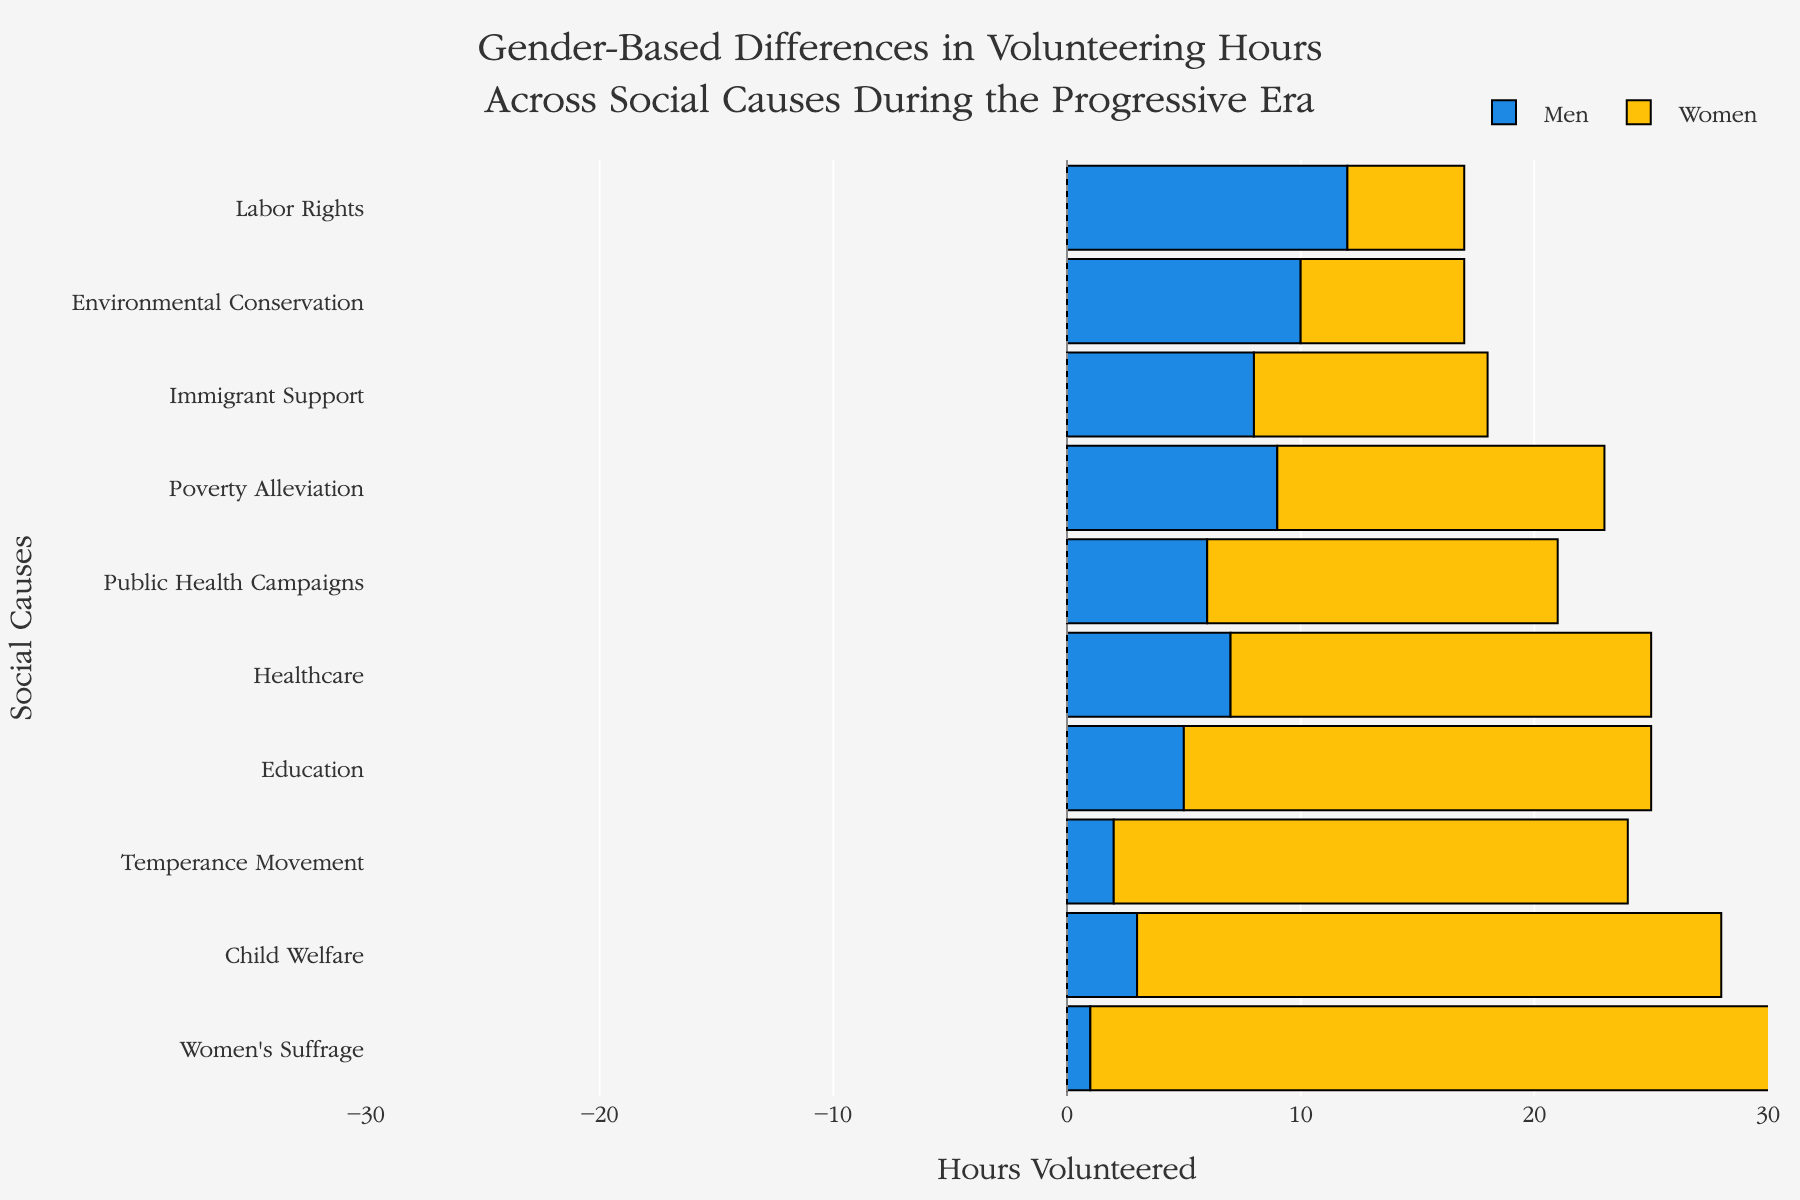What's the total number of volunteered hours for Men in Health-related causes (Healthcare and Public Health Campaigns)? Sum up the volunteered hours of Men for Healthcare and Public Health Campaigns: 7 hours (Healthcare) + 6 hours (Public Health Campaigns) = 13 hours
Answer: 13 Which cause had the largest difference in volunteered hours between Men and Women? Look at the bars representing the difference for all causes. The biggest difference is for Women's Suffrage where Women volunteered 30 hours and Men only 1 hour, difference is 29 hours
Answer: Women's Suffrage Are there any causes where Men and Women volunteered the same amount of time? Compare the bars for each cause to see if they are of equal length. There are no bars with equal lengths, hence no cause where Men and Women volunteered the same amount of time
Answer: No Which gender volunteered more hours for Environmental Conservation? Compare the lengths of the bars for Men and Women in Environmental Conservation. Men's bar is longer with 10 hours compared to Women's bar with 7 hours
Answer: Men How much more time did Women volunteer in Child Welfare compared to Men? Look at the bars for Child Welfare. Women volunteered 25 hours and Men volunteered 3 hours. The difference is 25 - 3 = 22 hours
Answer: 22 What's the total number of volunteered hours for both Men and Women combined in Temperance Movement? Add the hours volunteered by Men and Women in Temperance Movement: 2 hours (Men) + 22 hours (Women) = 24 hours
Answer: 24 In which cause did Men volunteer twice or more hours than Women? Compare the bars where Men volunteered twice or more than Women. This occurs in Labor Rights (12 hours for Men vs. 5 hours for Women), and Immigrant Support (8 hours for Men vs. 10 hours for Women doesn't qualify)
Answer: Labor Rights How much more time did Women volunteer in Education compared to Men? Look at the bars for Education. Women volunteered 20 hours and Men volunteered 5 hours. The difference is 20 - 5 = 15 hours
Answer: 15 Which cause has the smallest difference in volunteering hours between Men and Women? Look at the smaller differences in the lengths of the bars. The smallest difference is in Immigrant Support where Women volunteered 10 hours and Men 8 hours, difference is 2 hours
Answer: Immigrant Support Are any causes where Women volunteered less than Men? Observing all causes, Women volunteered less than Men in Labor Rights (12 hours for Men vs. 5 for Women) and Environmental Conservation (10 hours for Men vs. 7 for Women)
Answer: Yes 